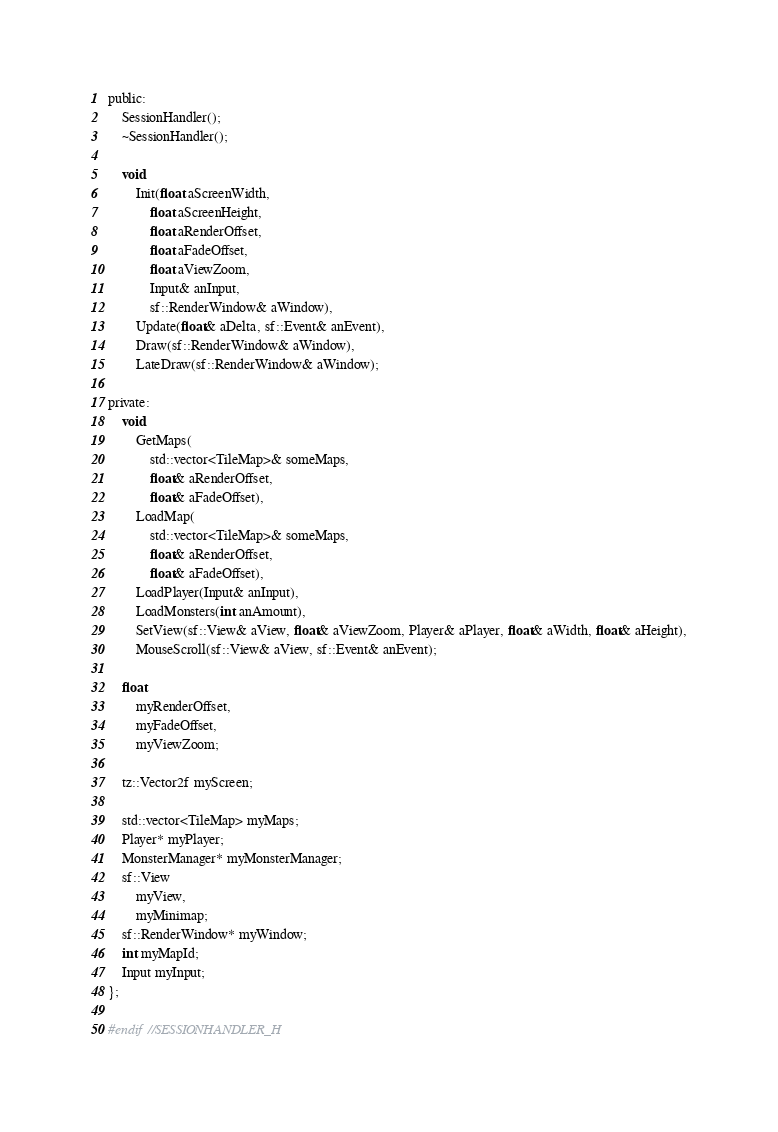Convert code to text. <code><loc_0><loc_0><loc_500><loc_500><_C_>public:
	SessionHandler();
	~SessionHandler();

	void
		Init(float aScreenWidth,
			float aScreenHeight,
			float aRenderOffset,
			float aFadeOffset,
			float aViewZoom,
			Input& anInput,
			sf::RenderWindow& aWindow),
		Update(float& aDelta, sf::Event& anEvent),
		Draw(sf::RenderWindow& aWindow),
		LateDraw(sf::RenderWindow& aWindow);

private:
	void
		GetMaps(
			std::vector<TileMap>& someMaps,
			float& aRenderOffset,
			float& aFadeOffset),
		LoadMap(
			std::vector<TileMap>& someMaps,
			float& aRenderOffset,
			float& aFadeOffset),
		LoadPlayer(Input& anInput),
		LoadMonsters(int anAmount),
		SetView(sf::View& aView, float& aViewZoom, Player& aPlayer, float& aWidth, float& aHeight),
		MouseScroll(sf::View& aView, sf::Event& anEvent);

	float
		myRenderOffset,
		myFadeOffset,
		myViewZoom;

	tz::Vector2f myScreen;

	std::vector<TileMap> myMaps;
	Player* myPlayer;
	MonsterManager* myMonsterManager;
	sf::View
		myView,
		myMinimap;
	sf::RenderWindow* myWindow;
	int myMapId;
	Input myInput;
};

#endif //SESSIONHANDLER_H
</code> 